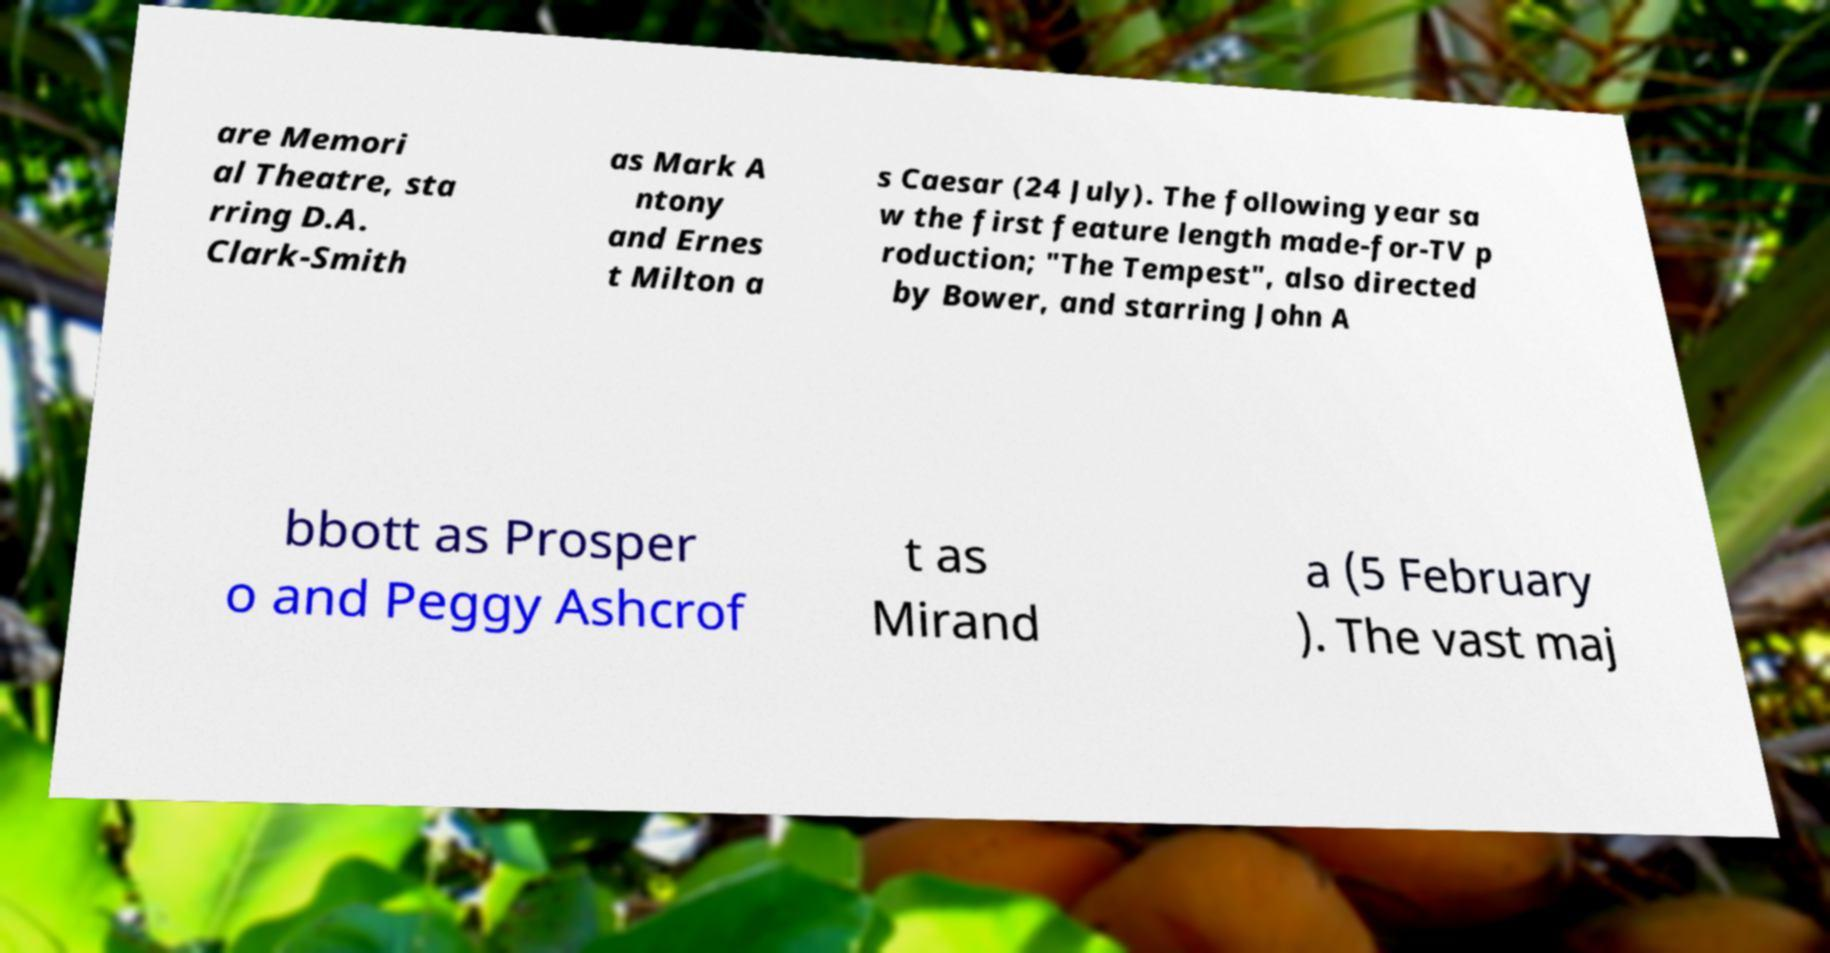Please read and relay the text visible in this image. What does it say? are Memori al Theatre, sta rring D.A. Clark-Smith as Mark A ntony and Ernes t Milton a s Caesar (24 July). The following year sa w the first feature length made-for-TV p roduction; "The Tempest", also directed by Bower, and starring John A bbott as Prosper o and Peggy Ashcrof t as Mirand a (5 February ). The vast maj 